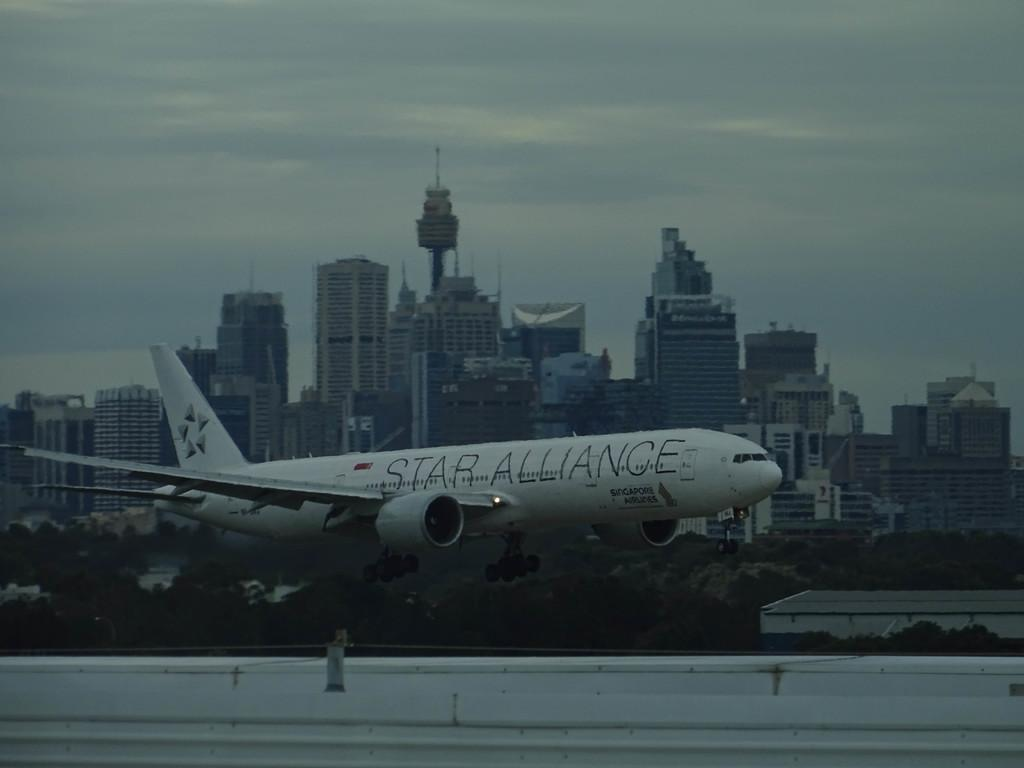Provide a one-sentence caption for the provided image. Star Alliance plane on runway in city with tall buildings. 